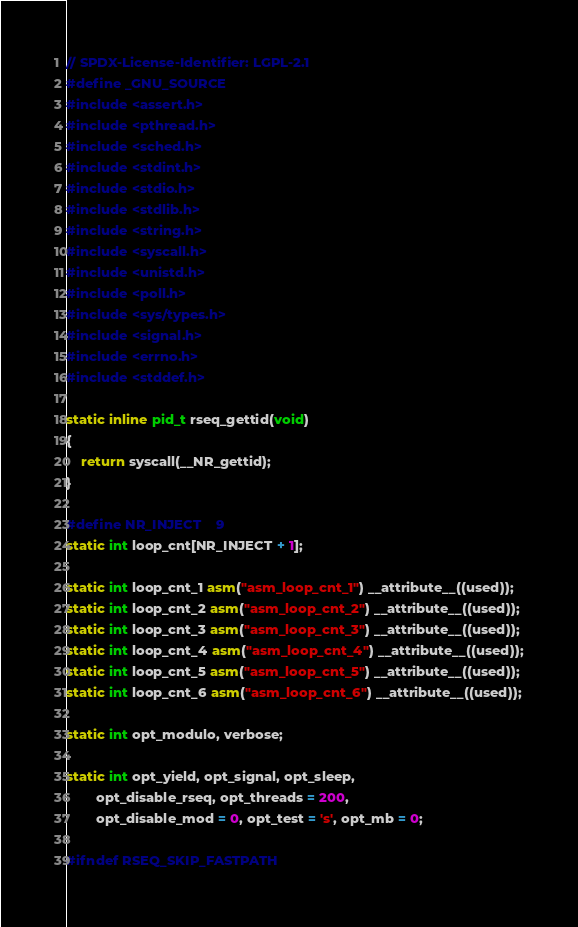<code> <loc_0><loc_0><loc_500><loc_500><_C_>// SPDX-License-Identifier: LGPL-2.1
#define _GNU_SOURCE
#include <assert.h>
#include <pthread.h>
#include <sched.h>
#include <stdint.h>
#include <stdio.h>
#include <stdlib.h>
#include <string.h>
#include <syscall.h>
#include <unistd.h>
#include <poll.h>
#include <sys/types.h>
#include <signal.h>
#include <errno.h>
#include <stddef.h>

static inline pid_t rseq_gettid(void)
{
	return syscall(__NR_gettid);
}

#define NR_INJECT	9
static int loop_cnt[NR_INJECT + 1];

static int loop_cnt_1 asm("asm_loop_cnt_1") __attribute__((used));
static int loop_cnt_2 asm("asm_loop_cnt_2") __attribute__((used));
static int loop_cnt_3 asm("asm_loop_cnt_3") __attribute__((used));
static int loop_cnt_4 asm("asm_loop_cnt_4") __attribute__((used));
static int loop_cnt_5 asm("asm_loop_cnt_5") __attribute__((used));
static int loop_cnt_6 asm("asm_loop_cnt_6") __attribute__((used));

static int opt_modulo, verbose;

static int opt_yield, opt_signal, opt_sleep,
		opt_disable_rseq, opt_threads = 200,
		opt_disable_mod = 0, opt_test = 's', opt_mb = 0;

#ifndef RSEQ_SKIP_FASTPATH</code> 